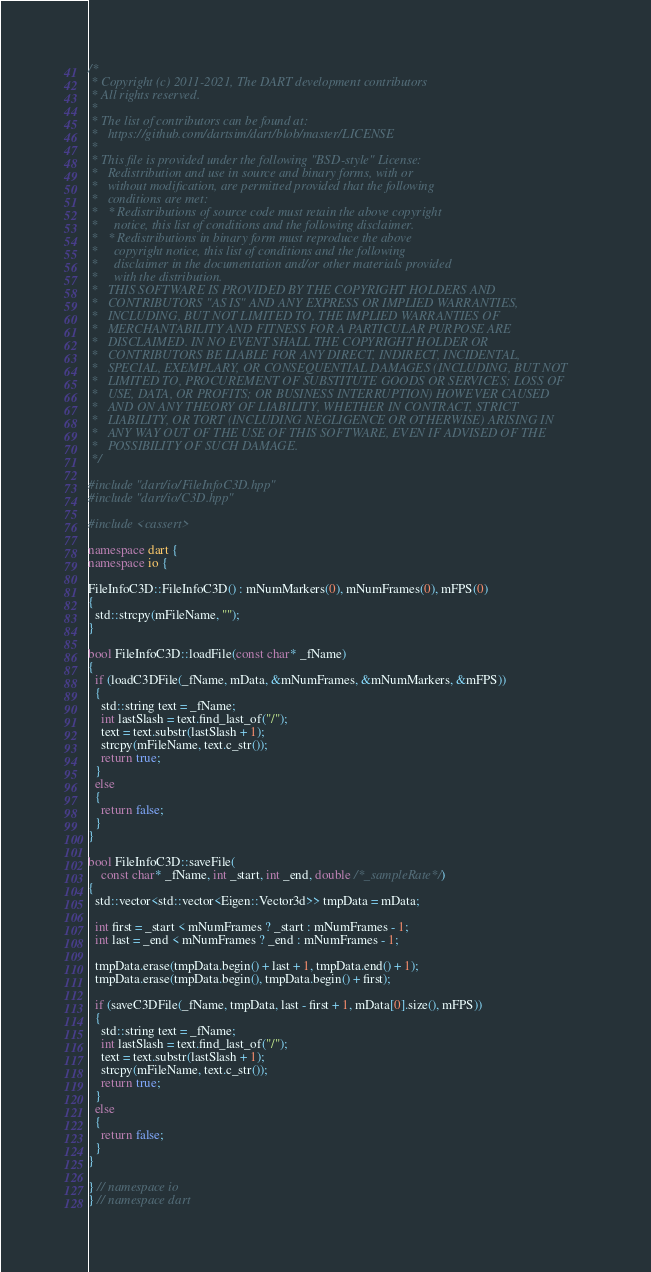<code> <loc_0><loc_0><loc_500><loc_500><_C++_>/*
 * Copyright (c) 2011-2021, The DART development contributors
 * All rights reserved.
 *
 * The list of contributors can be found at:
 *   https://github.com/dartsim/dart/blob/master/LICENSE
 *
 * This file is provided under the following "BSD-style" License:
 *   Redistribution and use in source and binary forms, with or
 *   without modification, are permitted provided that the following
 *   conditions are met:
 *   * Redistributions of source code must retain the above copyright
 *     notice, this list of conditions and the following disclaimer.
 *   * Redistributions in binary form must reproduce the above
 *     copyright notice, this list of conditions and the following
 *     disclaimer in the documentation and/or other materials provided
 *     with the distribution.
 *   THIS SOFTWARE IS PROVIDED BY THE COPYRIGHT HOLDERS AND
 *   CONTRIBUTORS "AS IS" AND ANY EXPRESS OR IMPLIED WARRANTIES,
 *   INCLUDING, BUT NOT LIMITED TO, THE IMPLIED WARRANTIES OF
 *   MERCHANTABILITY AND FITNESS FOR A PARTICULAR PURPOSE ARE
 *   DISCLAIMED. IN NO EVENT SHALL THE COPYRIGHT HOLDER OR
 *   CONTRIBUTORS BE LIABLE FOR ANY DIRECT, INDIRECT, INCIDENTAL,
 *   SPECIAL, EXEMPLARY, OR CONSEQUENTIAL DAMAGES (INCLUDING, BUT NOT
 *   LIMITED TO, PROCUREMENT OF SUBSTITUTE GOODS OR SERVICES; LOSS OF
 *   USE, DATA, OR PROFITS; OR BUSINESS INTERRUPTION) HOWEVER CAUSED
 *   AND ON ANY THEORY OF LIABILITY, WHETHER IN CONTRACT, STRICT
 *   LIABILITY, OR TORT (INCLUDING NEGLIGENCE OR OTHERWISE) ARISING IN
 *   ANY WAY OUT OF THE USE OF THIS SOFTWARE, EVEN IF ADVISED OF THE
 *   POSSIBILITY OF SUCH DAMAGE.
 */

#include "dart/io/FileInfoC3D.hpp"
#include "dart/io/C3D.hpp"

#include <cassert>

namespace dart {
namespace io {

FileInfoC3D::FileInfoC3D() : mNumMarkers(0), mNumFrames(0), mFPS(0)
{
  std::strcpy(mFileName, "");
}

bool FileInfoC3D::loadFile(const char* _fName)
{
  if (loadC3DFile(_fName, mData, &mNumFrames, &mNumMarkers, &mFPS))
  {
    std::string text = _fName;
    int lastSlash = text.find_last_of("/");
    text = text.substr(lastSlash + 1);
    strcpy(mFileName, text.c_str());
    return true;
  }
  else
  {
    return false;
  }
}

bool FileInfoC3D::saveFile(
    const char* _fName, int _start, int _end, double /*_sampleRate*/)
{
  std::vector<std::vector<Eigen::Vector3d>> tmpData = mData;

  int first = _start < mNumFrames ? _start : mNumFrames - 1;
  int last = _end < mNumFrames ? _end : mNumFrames - 1;

  tmpData.erase(tmpData.begin() + last + 1, tmpData.end() + 1);
  tmpData.erase(tmpData.begin(), tmpData.begin() + first);

  if (saveC3DFile(_fName, tmpData, last - first + 1, mData[0].size(), mFPS))
  {
    std::string text = _fName;
    int lastSlash = text.find_last_of("/");
    text = text.substr(lastSlash + 1);
    strcpy(mFileName, text.c_str());
    return true;
  }
  else
  {
    return false;
  }
}

} // namespace io
} // namespace dart
</code> 